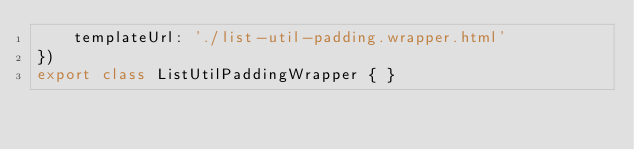<code> <loc_0><loc_0><loc_500><loc_500><_TypeScript_>    templateUrl: './list-util-padding.wrapper.html'
})
export class ListUtilPaddingWrapper { }
</code> 